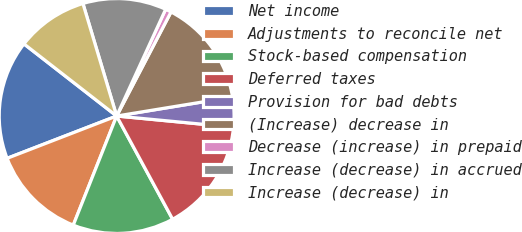Convert chart. <chart><loc_0><loc_0><loc_500><loc_500><pie_chart><fcel>Net income<fcel>Adjustments to reconcile net<fcel>Stock-based compensation<fcel>Deferred taxes<fcel>Provision for bad debts<fcel>(Increase) decrease in<fcel>Decrease (increase) in prepaid<fcel>Increase (decrease) in accrued<fcel>Increase (decrease) in<nl><fcel>16.39%<fcel>13.11%<fcel>13.93%<fcel>15.57%<fcel>4.1%<fcel>14.75%<fcel>0.82%<fcel>11.48%<fcel>9.84%<nl></chart> 